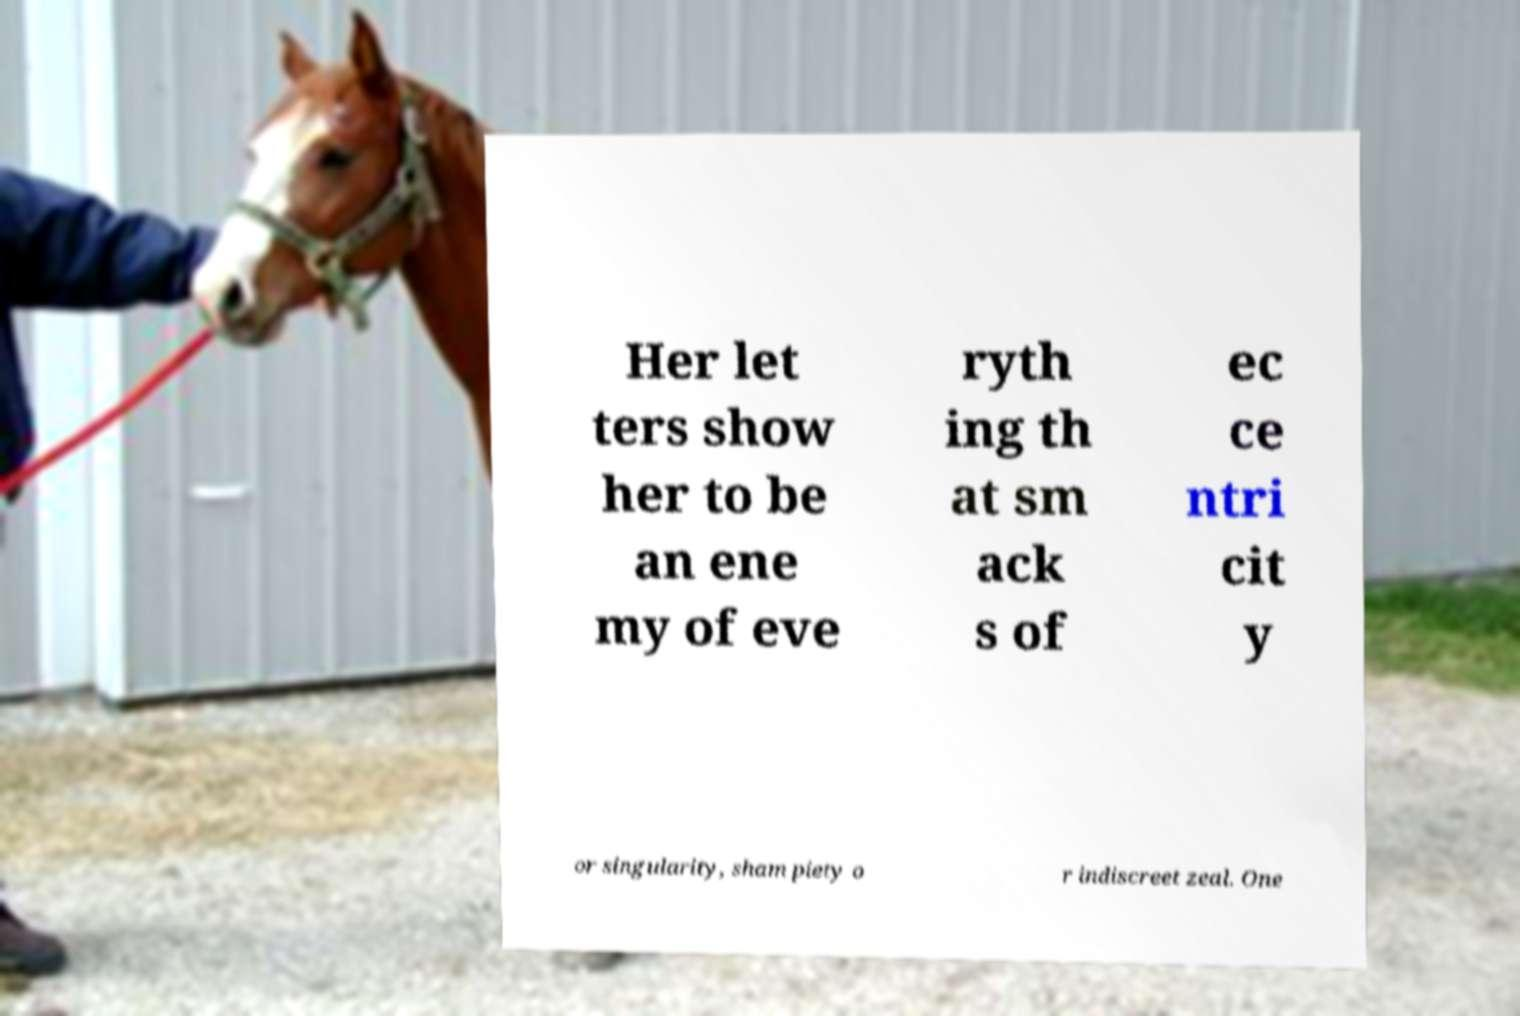Please identify and transcribe the text found in this image. Her let ters show her to be an ene my of eve ryth ing th at sm ack s of ec ce ntri cit y or singularity, sham piety o r indiscreet zeal. One 